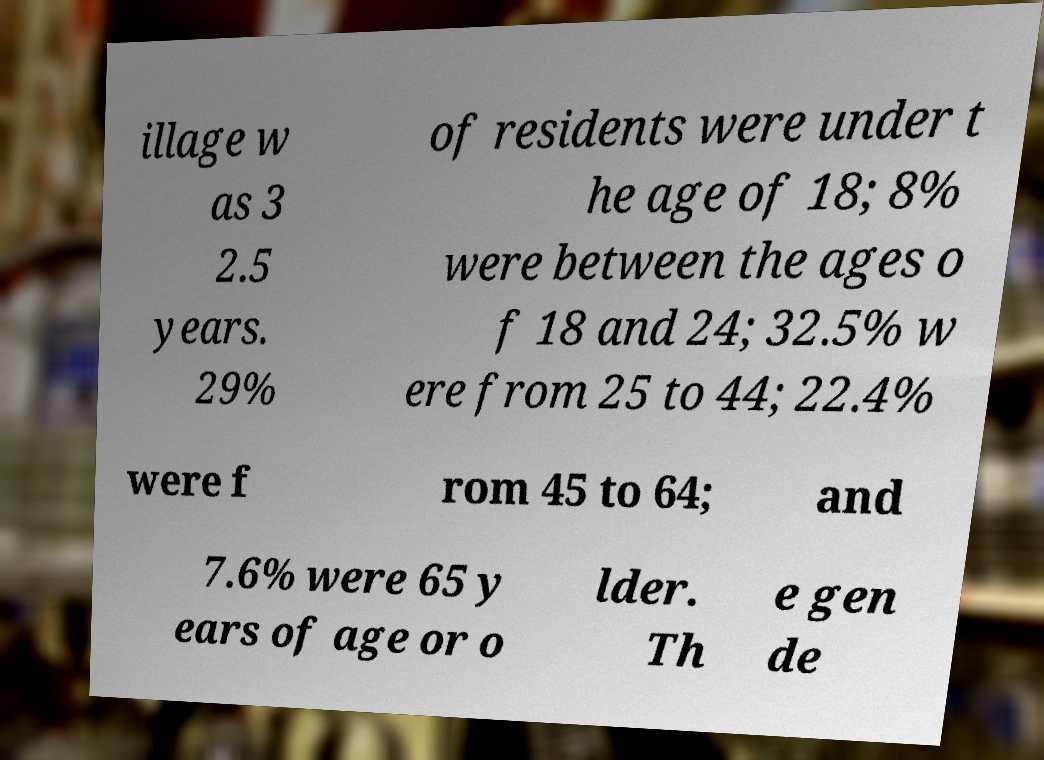Can you accurately transcribe the text from the provided image for me? illage w as 3 2.5 years. 29% of residents were under t he age of 18; 8% were between the ages o f 18 and 24; 32.5% w ere from 25 to 44; 22.4% were f rom 45 to 64; and 7.6% were 65 y ears of age or o lder. Th e gen de 